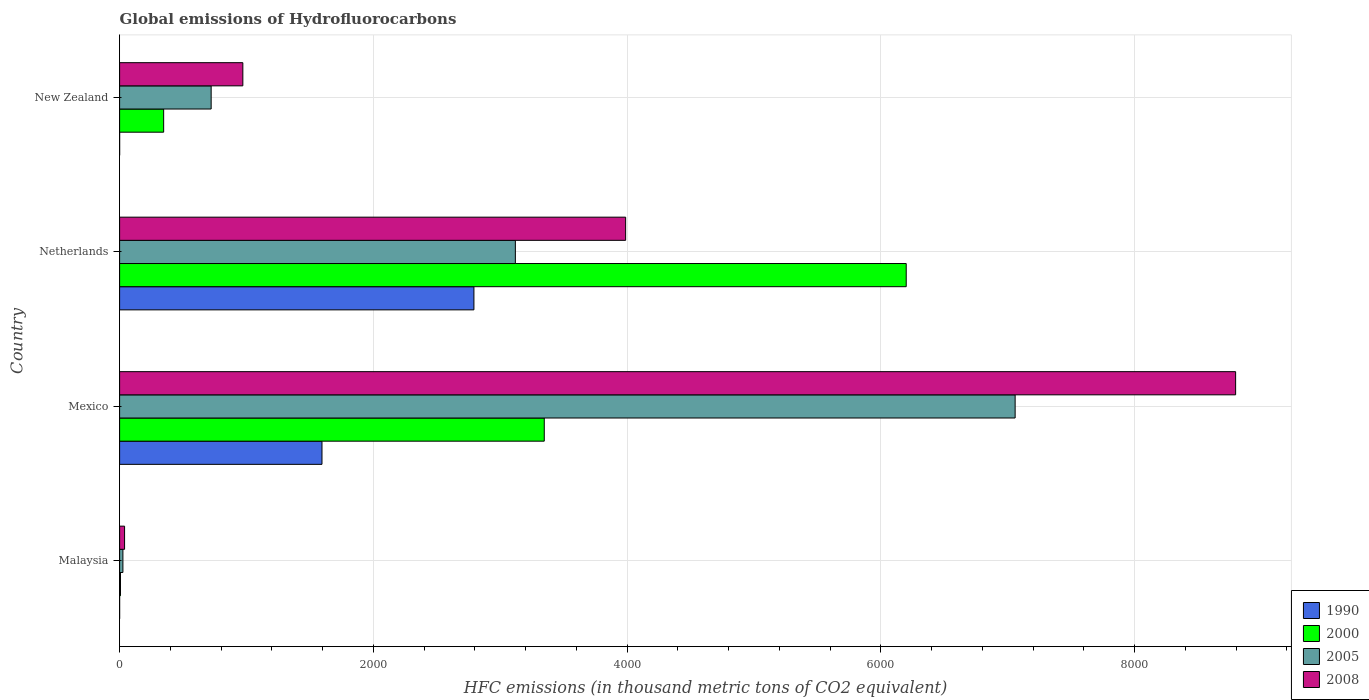Are the number of bars on each tick of the Y-axis equal?
Offer a terse response. Yes. How many bars are there on the 2nd tick from the top?
Your answer should be compact. 4. In how many cases, is the number of bars for a given country not equal to the number of legend labels?
Provide a succinct answer. 0. What is the global emissions of Hydrofluorocarbons in 2008 in New Zealand?
Give a very brief answer. 971.4. Across all countries, what is the maximum global emissions of Hydrofluorocarbons in 1990?
Provide a succinct answer. 2792.9. Across all countries, what is the minimum global emissions of Hydrofluorocarbons in 2005?
Keep it short and to the point. 26.1. In which country was the global emissions of Hydrofluorocarbons in 1990 minimum?
Provide a succinct answer. Malaysia. What is the total global emissions of Hydrofluorocarbons in 2000 in the graph?
Ensure brevity in your answer.  9901.9. What is the difference between the global emissions of Hydrofluorocarbons in 2005 in Malaysia and that in New Zealand?
Your answer should be compact. -695.6. What is the difference between the global emissions of Hydrofluorocarbons in 1990 in Mexico and the global emissions of Hydrofluorocarbons in 2008 in Netherlands?
Your answer should be very brief. -2393.5. What is the average global emissions of Hydrofluorocarbons in 1990 per country?
Provide a short and direct response. 1097.12. What is the difference between the global emissions of Hydrofluorocarbons in 1990 and global emissions of Hydrofluorocarbons in 2000 in Mexico?
Your answer should be compact. -1752. In how many countries, is the global emissions of Hydrofluorocarbons in 1990 greater than 4000 thousand metric tons?
Offer a terse response. 0. What is the ratio of the global emissions of Hydrofluorocarbons in 2008 in Mexico to that in New Zealand?
Your response must be concise. 9.06. What is the difference between the highest and the second highest global emissions of Hydrofluorocarbons in 1990?
Provide a short and direct response. 1197.6. What is the difference between the highest and the lowest global emissions of Hydrofluorocarbons in 1990?
Provide a succinct answer. 2792.8. In how many countries, is the global emissions of Hydrofluorocarbons in 2000 greater than the average global emissions of Hydrofluorocarbons in 2000 taken over all countries?
Offer a very short reply. 2. Is the sum of the global emissions of Hydrofluorocarbons in 2008 in Malaysia and Mexico greater than the maximum global emissions of Hydrofluorocarbons in 2000 across all countries?
Your answer should be very brief. Yes. What does the 4th bar from the top in Netherlands represents?
Give a very brief answer. 1990. Is it the case that in every country, the sum of the global emissions of Hydrofluorocarbons in 2008 and global emissions of Hydrofluorocarbons in 2000 is greater than the global emissions of Hydrofluorocarbons in 1990?
Give a very brief answer. Yes. How many bars are there?
Offer a very short reply. 16. What is the difference between two consecutive major ticks on the X-axis?
Provide a short and direct response. 2000. Are the values on the major ticks of X-axis written in scientific E-notation?
Your answer should be compact. No. Does the graph contain any zero values?
Make the answer very short. No. How are the legend labels stacked?
Your answer should be very brief. Vertical. What is the title of the graph?
Provide a succinct answer. Global emissions of Hydrofluorocarbons. What is the label or title of the X-axis?
Make the answer very short. HFC emissions (in thousand metric tons of CO2 equivalent). What is the HFC emissions (in thousand metric tons of CO2 equivalent) of 2005 in Malaysia?
Make the answer very short. 26.1. What is the HFC emissions (in thousand metric tons of CO2 equivalent) in 2008 in Malaysia?
Give a very brief answer. 39.2. What is the HFC emissions (in thousand metric tons of CO2 equivalent) in 1990 in Mexico?
Offer a terse response. 1595.3. What is the HFC emissions (in thousand metric tons of CO2 equivalent) of 2000 in Mexico?
Keep it short and to the point. 3347.3. What is the HFC emissions (in thousand metric tons of CO2 equivalent) of 2005 in Mexico?
Your answer should be compact. 7058.9. What is the HFC emissions (in thousand metric tons of CO2 equivalent) in 2008 in Mexico?
Give a very brief answer. 8796.9. What is the HFC emissions (in thousand metric tons of CO2 equivalent) of 1990 in Netherlands?
Give a very brief answer. 2792.9. What is the HFC emissions (in thousand metric tons of CO2 equivalent) in 2000 in Netherlands?
Ensure brevity in your answer.  6200.4. What is the HFC emissions (in thousand metric tons of CO2 equivalent) in 2005 in Netherlands?
Offer a terse response. 3119.5. What is the HFC emissions (in thousand metric tons of CO2 equivalent) of 2008 in Netherlands?
Provide a short and direct response. 3988.8. What is the HFC emissions (in thousand metric tons of CO2 equivalent) of 1990 in New Zealand?
Provide a succinct answer. 0.2. What is the HFC emissions (in thousand metric tons of CO2 equivalent) of 2000 in New Zealand?
Ensure brevity in your answer.  347.3. What is the HFC emissions (in thousand metric tons of CO2 equivalent) in 2005 in New Zealand?
Offer a very short reply. 721.7. What is the HFC emissions (in thousand metric tons of CO2 equivalent) of 2008 in New Zealand?
Give a very brief answer. 971.4. Across all countries, what is the maximum HFC emissions (in thousand metric tons of CO2 equivalent) of 1990?
Make the answer very short. 2792.9. Across all countries, what is the maximum HFC emissions (in thousand metric tons of CO2 equivalent) in 2000?
Provide a short and direct response. 6200.4. Across all countries, what is the maximum HFC emissions (in thousand metric tons of CO2 equivalent) of 2005?
Make the answer very short. 7058.9. Across all countries, what is the maximum HFC emissions (in thousand metric tons of CO2 equivalent) in 2008?
Provide a short and direct response. 8796.9. Across all countries, what is the minimum HFC emissions (in thousand metric tons of CO2 equivalent) of 2005?
Your answer should be compact. 26.1. Across all countries, what is the minimum HFC emissions (in thousand metric tons of CO2 equivalent) of 2008?
Your answer should be compact. 39.2. What is the total HFC emissions (in thousand metric tons of CO2 equivalent) in 1990 in the graph?
Offer a terse response. 4388.5. What is the total HFC emissions (in thousand metric tons of CO2 equivalent) of 2000 in the graph?
Offer a terse response. 9901.9. What is the total HFC emissions (in thousand metric tons of CO2 equivalent) in 2005 in the graph?
Offer a very short reply. 1.09e+04. What is the total HFC emissions (in thousand metric tons of CO2 equivalent) in 2008 in the graph?
Your response must be concise. 1.38e+04. What is the difference between the HFC emissions (in thousand metric tons of CO2 equivalent) in 1990 in Malaysia and that in Mexico?
Provide a succinct answer. -1595.2. What is the difference between the HFC emissions (in thousand metric tons of CO2 equivalent) in 2000 in Malaysia and that in Mexico?
Offer a terse response. -3340.4. What is the difference between the HFC emissions (in thousand metric tons of CO2 equivalent) in 2005 in Malaysia and that in Mexico?
Provide a succinct answer. -7032.8. What is the difference between the HFC emissions (in thousand metric tons of CO2 equivalent) in 2008 in Malaysia and that in Mexico?
Your answer should be compact. -8757.7. What is the difference between the HFC emissions (in thousand metric tons of CO2 equivalent) in 1990 in Malaysia and that in Netherlands?
Ensure brevity in your answer.  -2792.8. What is the difference between the HFC emissions (in thousand metric tons of CO2 equivalent) in 2000 in Malaysia and that in Netherlands?
Provide a succinct answer. -6193.5. What is the difference between the HFC emissions (in thousand metric tons of CO2 equivalent) in 2005 in Malaysia and that in Netherlands?
Provide a succinct answer. -3093.4. What is the difference between the HFC emissions (in thousand metric tons of CO2 equivalent) in 2008 in Malaysia and that in Netherlands?
Give a very brief answer. -3949.6. What is the difference between the HFC emissions (in thousand metric tons of CO2 equivalent) of 2000 in Malaysia and that in New Zealand?
Your answer should be very brief. -340.4. What is the difference between the HFC emissions (in thousand metric tons of CO2 equivalent) of 2005 in Malaysia and that in New Zealand?
Provide a short and direct response. -695.6. What is the difference between the HFC emissions (in thousand metric tons of CO2 equivalent) of 2008 in Malaysia and that in New Zealand?
Your answer should be very brief. -932.2. What is the difference between the HFC emissions (in thousand metric tons of CO2 equivalent) in 1990 in Mexico and that in Netherlands?
Make the answer very short. -1197.6. What is the difference between the HFC emissions (in thousand metric tons of CO2 equivalent) in 2000 in Mexico and that in Netherlands?
Give a very brief answer. -2853.1. What is the difference between the HFC emissions (in thousand metric tons of CO2 equivalent) in 2005 in Mexico and that in Netherlands?
Offer a very short reply. 3939.4. What is the difference between the HFC emissions (in thousand metric tons of CO2 equivalent) of 2008 in Mexico and that in Netherlands?
Your response must be concise. 4808.1. What is the difference between the HFC emissions (in thousand metric tons of CO2 equivalent) of 1990 in Mexico and that in New Zealand?
Keep it short and to the point. 1595.1. What is the difference between the HFC emissions (in thousand metric tons of CO2 equivalent) in 2000 in Mexico and that in New Zealand?
Your answer should be compact. 3000. What is the difference between the HFC emissions (in thousand metric tons of CO2 equivalent) of 2005 in Mexico and that in New Zealand?
Give a very brief answer. 6337.2. What is the difference between the HFC emissions (in thousand metric tons of CO2 equivalent) of 2008 in Mexico and that in New Zealand?
Provide a short and direct response. 7825.5. What is the difference between the HFC emissions (in thousand metric tons of CO2 equivalent) in 1990 in Netherlands and that in New Zealand?
Make the answer very short. 2792.7. What is the difference between the HFC emissions (in thousand metric tons of CO2 equivalent) of 2000 in Netherlands and that in New Zealand?
Offer a very short reply. 5853.1. What is the difference between the HFC emissions (in thousand metric tons of CO2 equivalent) of 2005 in Netherlands and that in New Zealand?
Your answer should be compact. 2397.8. What is the difference between the HFC emissions (in thousand metric tons of CO2 equivalent) of 2008 in Netherlands and that in New Zealand?
Provide a succinct answer. 3017.4. What is the difference between the HFC emissions (in thousand metric tons of CO2 equivalent) in 1990 in Malaysia and the HFC emissions (in thousand metric tons of CO2 equivalent) in 2000 in Mexico?
Provide a short and direct response. -3347.2. What is the difference between the HFC emissions (in thousand metric tons of CO2 equivalent) in 1990 in Malaysia and the HFC emissions (in thousand metric tons of CO2 equivalent) in 2005 in Mexico?
Give a very brief answer. -7058.8. What is the difference between the HFC emissions (in thousand metric tons of CO2 equivalent) of 1990 in Malaysia and the HFC emissions (in thousand metric tons of CO2 equivalent) of 2008 in Mexico?
Your answer should be compact. -8796.8. What is the difference between the HFC emissions (in thousand metric tons of CO2 equivalent) of 2000 in Malaysia and the HFC emissions (in thousand metric tons of CO2 equivalent) of 2005 in Mexico?
Your answer should be compact. -7052. What is the difference between the HFC emissions (in thousand metric tons of CO2 equivalent) in 2000 in Malaysia and the HFC emissions (in thousand metric tons of CO2 equivalent) in 2008 in Mexico?
Your answer should be very brief. -8790. What is the difference between the HFC emissions (in thousand metric tons of CO2 equivalent) in 2005 in Malaysia and the HFC emissions (in thousand metric tons of CO2 equivalent) in 2008 in Mexico?
Ensure brevity in your answer.  -8770.8. What is the difference between the HFC emissions (in thousand metric tons of CO2 equivalent) of 1990 in Malaysia and the HFC emissions (in thousand metric tons of CO2 equivalent) of 2000 in Netherlands?
Your response must be concise. -6200.3. What is the difference between the HFC emissions (in thousand metric tons of CO2 equivalent) of 1990 in Malaysia and the HFC emissions (in thousand metric tons of CO2 equivalent) of 2005 in Netherlands?
Your answer should be very brief. -3119.4. What is the difference between the HFC emissions (in thousand metric tons of CO2 equivalent) of 1990 in Malaysia and the HFC emissions (in thousand metric tons of CO2 equivalent) of 2008 in Netherlands?
Offer a terse response. -3988.7. What is the difference between the HFC emissions (in thousand metric tons of CO2 equivalent) in 2000 in Malaysia and the HFC emissions (in thousand metric tons of CO2 equivalent) in 2005 in Netherlands?
Ensure brevity in your answer.  -3112.6. What is the difference between the HFC emissions (in thousand metric tons of CO2 equivalent) in 2000 in Malaysia and the HFC emissions (in thousand metric tons of CO2 equivalent) in 2008 in Netherlands?
Your answer should be compact. -3981.9. What is the difference between the HFC emissions (in thousand metric tons of CO2 equivalent) in 2005 in Malaysia and the HFC emissions (in thousand metric tons of CO2 equivalent) in 2008 in Netherlands?
Ensure brevity in your answer.  -3962.7. What is the difference between the HFC emissions (in thousand metric tons of CO2 equivalent) of 1990 in Malaysia and the HFC emissions (in thousand metric tons of CO2 equivalent) of 2000 in New Zealand?
Ensure brevity in your answer.  -347.2. What is the difference between the HFC emissions (in thousand metric tons of CO2 equivalent) in 1990 in Malaysia and the HFC emissions (in thousand metric tons of CO2 equivalent) in 2005 in New Zealand?
Keep it short and to the point. -721.6. What is the difference between the HFC emissions (in thousand metric tons of CO2 equivalent) in 1990 in Malaysia and the HFC emissions (in thousand metric tons of CO2 equivalent) in 2008 in New Zealand?
Keep it short and to the point. -971.3. What is the difference between the HFC emissions (in thousand metric tons of CO2 equivalent) of 2000 in Malaysia and the HFC emissions (in thousand metric tons of CO2 equivalent) of 2005 in New Zealand?
Keep it short and to the point. -714.8. What is the difference between the HFC emissions (in thousand metric tons of CO2 equivalent) in 2000 in Malaysia and the HFC emissions (in thousand metric tons of CO2 equivalent) in 2008 in New Zealand?
Give a very brief answer. -964.5. What is the difference between the HFC emissions (in thousand metric tons of CO2 equivalent) in 2005 in Malaysia and the HFC emissions (in thousand metric tons of CO2 equivalent) in 2008 in New Zealand?
Provide a short and direct response. -945.3. What is the difference between the HFC emissions (in thousand metric tons of CO2 equivalent) of 1990 in Mexico and the HFC emissions (in thousand metric tons of CO2 equivalent) of 2000 in Netherlands?
Make the answer very short. -4605.1. What is the difference between the HFC emissions (in thousand metric tons of CO2 equivalent) of 1990 in Mexico and the HFC emissions (in thousand metric tons of CO2 equivalent) of 2005 in Netherlands?
Give a very brief answer. -1524.2. What is the difference between the HFC emissions (in thousand metric tons of CO2 equivalent) in 1990 in Mexico and the HFC emissions (in thousand metric tons of CO2 equivalent) in 2008 in Netherlands?
Provide a succinct answer. -2393.5. What is the difference between the HFC emissions (in thousand metric tons of CO2 equivalent) of 2000 in Mexico and the HFC emissions (in thousand metric tons of CO2 equivalent) of 2005 in Netherlands?
Your answer should be very brief. 227.8. What is the difference between the HFC emissions (in thousand metric tons of CO2 equivalent) in 2000 in Mexico and the HFC emissions (in thousand metric tons of CO2 equivalent) in 2008 in Netherlands?
Your answer should be compact. -641.5. What is the difference between the HFC emissions (in thousand metric tons of CO2 equivalent) of 2005 in Mexico and the HFC emissions (in thousand metric tons of CO2 equivalent) of 2008 in Netherlands?
Make the answer very short. 3070.1. What is the difference between the HFC emissions (in thousand metric tons of CO2 equivalent) of 1990 in Mexico and the HFC emissions (in thousand metric tons of CO2 equivalent) of 2000 in New Zealand?
Ensure brevity in your answer.  1248. What is the difference between the HFC emissions (in thousand metric tons of CO2 equivalent) of 1990 in Mexico and the HFC emissions (in thousand metric tons of CO2 equivalent) of 2005 in New Zealand?
Offer a terse response. 873.6. What is the difference between the HFC emissions (in thousand metric tons of CO2 equivalent) in 1990 in Mexico and the HFC emissions (in thousand metric tons of CO2 equivalent) in 2008 in New Zealand?
Your answer should be very brief. 623.9. What is the difference between the HFC emissions (in thousand metric tons of CO2 equivalent) in 2000 in Mexico and the HFC emissions (in thousand metric tons of CO2 equivalent) in 2005 in New Zealand?
Your answer should be very brief. 2625.6. What is the difference between the HFC emissions (in thousand metric tons of CO2 equivalent) in 2000 in Mexico and the HFC emissions (in thousand metric tons of CO2 equivalent) in 2008 in New Zealand?
Give a very brief answer. 2375.9. What is the difference between the HFC emissions (in thousand metric tons of CO2 equivalent) in 2005 in Mexico and the HFC emissions (in thousand metric tons of CO2 equivalent) in 2008 in New Zealand?
Keep it short and to the point. 6087.5. What is the difference between the HFC emissions (in thousand metric tons of CO2 equivalent) of 1990 in Netherlands and the HFC emissions (in thousand metric tons of CO2 equivalent) of 2000 in New Zealand?
Provide a short and direct response. 2445.6. What is the difference between the HFC emissions (in thousand metric tons of CO2 equivalent) in 1990 in Netherlands and the HFC emissions (in thousand metric tons of CO2 equivalent) in 2005 in New Zealand?
Your answer should be very brief. 2071.2. What is the difference between the HFC emissions (in thousand metric tons of CO2 equivalent) in 1990 in Netherlands and the HFC emissions (in thousand metric tons of CO2 equivalent) in 2008 in New Zealand?
Make the answer very short. 1821.5. What is the difference between the HFC emissions (in thousand metric tons of CO2 equivalent) of 2000 in Netherlands and the HFC emissions (in thousand metric tons of CO2 equivalent) of 2005 in New Zealand?
Your response must be concise. 5478.7. What is the difference between the HFC emissions (in thousand metric tons of CO2 equivalent) of 2000 in Netherlands and the HFC emissions (in thousand metric tons of CO2 equivalent) of 2008 in New Zealand?
Provide a short and direct response. 5229. What is the difference between the HFC emissions (in thousand metric tons of CO2 equivalent) in 2005 in Netherlands and the HFC emissions (in thousand metric tons of CO2 equivalent) in 2008 in New Zealand?
Keep it short and to the point. 2148.1. What is the average HFC emissions (in thousand metric tons of CO2 equivalent) in 1990 per country?
Keep it short and to the point. 1097.12. What is the average HFC emissions (in thousand metric tons of CO2 equivalent) of 2000 per country?
Provide a short and direct response. 2475.47. What is the average HFC emissions (in thousand metric tons of CO2 equivalent) of 2005 per country?
Keep it short and to the point. 2731.55. What is the average HFC emissions (in thousand metric tons of CO2 equivalent) in 2008 per country?
Offer a very short reply. 3449.07. What is the difference between the HFC emissions (in thousand metric tons of CO2 equivalent) of 1990 and HFC emissions (in thousand metric tons of CO2 equivalent) of 2000 in Malaysia?
Your answer should be compact. -6.8. What is the difference between the HFC emissions (in thousand metric tons of CO2 equivalent) of 1990 and HFC emissions (in thousand metric tons of CO2 equivalent) of 2005 in Malaysia?
Your response must be concise. -26. What is the difference between the HFC emissions (in thousand metric tons of CO2 equivalent) in 1990 and HFC emissions (in thousand metric tons of CO2 equivalent) in 2008 in Malaysia?
Offer a very short reply. -39.1. What is the difference between the HFC emissions (in thousand metric tons of CO2 equivalent) in 2000 and HFC emissions (in thousand metric tons of CO2 equivalent) in 2005 in Malaysia?
Give a very brief answer. -19.2. What is the difference between the HFC emissions (in thousand metric tons of CO2 equivalent) of 2000 and HFC emissions (in thousand metric tons of CO2 equivalent) of 2008 in Malaysia?
Make the answer very short. -32.3. What is the difference between the HFC emissions (in thousand metric tons of CO2 equivalent) of 2005 and HFC emissions (in thousand metric tons of CO2 equivalent) of 2008 in Malaysia?
Ensure brevity in your answer.  -13.1. What is the difference between the HFC emissions (in thousand metric tons of CO2 equivalent) in 1990 and HFC emissions (in thousand metric tons of CO2 equivalent) in 2000 in Mexico?
Ensure brevity in your answer.  -1752. What is the difference between the HFC emissions (in thousand metric tons of CO2 equivalent) in 1990 and HFC emissions (in thousand metric tons of CO2 equivalent) in 2005 in Mexico?
Give a very brief answer. -5463.6. What is the difference between the HFC emissions (in thousand metric tons of CO2 equivalent) in 1990 and HFC emissions (in thousand metric tons of CO2 equivalent) in 2008 in Mexico?
Your answer should be compact. -7201.6. What is the difference between the HFC emissions (in thousand metric tons of CO2 equivalent) in 2000 and HFC emissions (in thousand metric tons of CO2 equivalent) in 2005 in Mexico?
Give a very brief answer. -3711.6. What is the difference between the HFC emissions (in thousand metric tons of CO2 equivalent) of 2000 and HFC emissions (in thousand metric tons of CO2 equivalent) of 2008 in Mexico?
Your answer should be very brief. -5449.6. What is the difference between the HFC emissions (in thousand metric tons of CO2 equivalent) of 2005 and HFC emissions (in thousand metric tons of CO2 equivalent) of 2008 in Mexico?
Give a very brief answer. -1738. What is the difference between the HFC emissions (in thousand metric tons of CO2 equivalent) in 1990 and HFC emissions (in thousand metric tons of CO2 equivalent) in 2000 in Netherlands?
Your response must be concise. -3407.5. What is the difference between the HFC emissions (in thousand metric tons of CO2 equivalent) in 1990 and HFC emissions (in thousand metric tons of CO2 equivalent) in 2005 in Netherlands?
Make the answer very short. -326.6. What is the difference between the HFC emissions (in thousand metric tons of CO2 equivalent) of 1990 and HFC emissions (in thousand metric tons of CO2 equivalent) of 2008 in Netherlands?
Your response must be concise. -1195.9. What is the difference between the HFC emissions (in thousand metric tons of CO2 equivalent) of 2000 and HFC emissions (in thousand metric tons of CO2 equivalent) of 2005 in Netherlands?
Your response must be concise. 3080.9. What is the difference between the HFC emissions (in thousand metric tons of CO2 equivalent) of 2000 and HFC emissions (in thousand metric tons of CO2 equivalent) of 2008 in Netherlands?
Your answer should be compact. 2211.6. What is the difference between the HFC emissions (in thousand metric tons of CO2 equivalent) of 2005 and HFC emissions (in thousand metric tons of CO2 equivalent) of 2008 in Netherlands?
Your answer should be compact. -869.3. What is the difference between the HFC emissions (in thousand metric tons of CO2 equivalent) in 1990 and HFC emissions (in thousand metric tons of CO2 equivalent) in 2000 in New Zealand?
Ensure brevity in your answer.  -347.1. What is the difference between the HFC emissions (in thousand metric tons of CO2 equivalent) of 1990 and HFC emissions (in thousand metric tons of CO2 equivalent) of 2005 in New Zealand?
Give a very brief answer. -721.5. What is the difference between the HFC emissions (in thousand metric tons of CO2 equivalent) of 1990 and HFC emissions (in thousand metric tons of CO2 equivalent) of 2008 in New Zealand?
Give a very brief answer. -971.2. What is the difference between the HFC emissions (in thousand metric tons of CO2 equivalent) in 2000 and HFC emissions (in thousand metric tons of CO2 equivalent) in 2005 in New Zealand?
Your answer should be very brief. -374.4. What is the difference between the HFC emissions (in thousand metric tons of CO2 equivalent) of 2000 and HFC emissions (in thousand metric tons of CO2 equivalent) of 2008 in New Zealand?
Keep it short and to the point. -624.1. What is the difference between the HFC emissions (in thousand metric tons of CO2 equivalent) in 2005 and HFC emissions (in thousand metric tons of CO2 equivalent) in 2008 in New Zealand?
Provide a succinct answer. -249.7. What is the ratio of the HFC emissions (in thousand metric tons of CO2 equivalent) of 2000 in Malaysia to that in Mexico?
Provide a short and direct response. 0. What is the ratio of the HFC emissions (in thousand metric tons of CO2 equivalent) in 2005 in Malaysia to that in Mexico?
Keep it short and to the point. 0. What is the ratio of the HFC emissions (in thousand metric tons of CO2 equivalent) in 2008 in Malaysia to that in Mexico?
Give a very brief answer. 0. What is the ratio of the HFC emissions (in thousand metric tons of CO2 equivalent) of 1990 in Malaysia to that in Netherlands?
Your response must be concise. 0. What is the ratio of the HFC emissions (in thousand metric tons of CO2 equivalent) of 2000 in Malaysia to that in Netherlands?
Offer a terse response. 0. What is the ratio of the HFC emissions (in thousand metric tons of CO2 equivalent) of 2005 in Malaysia to that in Netherlands?
Ensure brevity in your answer.  0.01. What is the ratio of the HFC emissions (in thousand metric tons of CO2 equivalent) of 2008 in Malaysia to that in Netherlands?
Your answer should be very brief. 0.01. What is the ratio of the HFC emissions (in thousand metric tons of CO2 equivalent) of 1990 in Malaysia to that in New Zealand?
Give a very brief answer. 0.5. What is the ratio of the HFC emissions (in thousand metric tons of CO2 equivalent) of 2000 in Malaysia to that in New Zealand?
Your answer should be very brief. 0.02. What is the ratio of the HFC emissions (in thousand metric tons of CO2 equivalent) in 2005 in Malaysia to that in New Zealand?
Your response must be concise. 0.04. What is the ratio of the HFC emissions (in thousand metric tons of CO2 equivalent) of 2008 in Malaysia to that in New Zealand?
Your answer should be very brief. 0.04. What is the ratio of the HFC emissions (in thousand metric tons of CO2 equivalent) in 1990 in Mexico to that in Netherlands?
Keep it short and to the point. 0.57. What is the ratio of the HFC emissions (in thousand metric tons of CO2 equivalent) in 2000 in Mexico to that in Netherlands?
Offer a terse response. 0.54. What is the ratio of the HFC emissions (in thousand metric tons of CO2 equivalent) in 2005 in Mexico to that in Netherlands?
Make the answer very short. 2.26. What is the ratio of the HFC emissions (in thousand metric tons of CO2 equivalent) of 2008 in Mexico to that in Netherlands?
Your response must be concise. 2.21. What is the ratio of the HFC emissions (in thousand metric tons of CO2 equivalent) in 1990 in Mexico to that in New Zealand?
Provide a succinct answer. 7976.5. What is the ratio of the HFC emissions (in thousand metric tons of CO2 equivalent) in 2000 in Mexico to that in New Zealand?
Provide a succinct answer. 9.64. What is the ratio of the HFC emissions (in thousand metric tons of CO2 equivalent) in 2005 in Mexico to that in New Zealand?
Offer a very short reply. 9.78. What is the ratio of the HFC emissions (in thousand metric tons of CO2 equivalent) in 2008 in Mexico to that in New Zealand?
Offer a very short reply. 9.06. What is the ratio of the HFC emissions (in thousand metric tons of CO2 equivalent) of 1990 in Netherlands to that in New Zealand?
Provide a short and direct response. 1.40e+04. What is the ratio of the HFC emissions (in thousand metric tons of CO2 equivalent) in 2000 in Netherlands to that in New Zealand?
Ensure brevity in your answer.  17.85. What is the ratio of the HFC emissions (in thousand metric tons of CO2 equivalent) in 2005 in Netherlands to that in New Zealand?
Your answer should be very brief. 4.32. What is the ratio of the HFC emissions (in thousand metric tons of CO2 equivalent) of 2008 in Netherlands to that in New Zealand?
Your response must be concise. 4.11. What is the difference between the highest and the second highest HFC emissions (in thousand metric tons of CO2 equivalent) of 1990?
Your answer should be compact. 1197.6. What is the difference between the highest and the second highest HFC emissions (in thousand metric tons of CO2 equivalent) in 2000?
Your answer should be compact. 2853.1. What is the difference between the highest and the second highest HFC emissions (in thousand metric tons of CO2 equivalent) of 2005?
Your answer should be compact. 3939.4. What is the difference between the highest and the second highest HFC emissions (in thousand metric tons of CO2 equivalent) of 2008?
Your answer should be compact. 4808.1. What is the difference between the highest and the lowest HFC emissions (in thousand metric tons of CO2 equivalent) of 1990?
Make the answer very short. 2792.8. What is the difference between the highest and the lowest HFC emissions (in thousand metric tons of CO2 equivalent) in 2000?
Ensure brevity in your answer.  6193.5. What is the difference between the highest and the lowest HFC emissions (in thousand metric tons of CO2 equivalent) of 2005?
Make the answer very short. 7032.8. What is the difference between the highest and the lowest HFC emissions (in thousand metric tons of CO2 equivalent) in 2008?
Your response must be concise. 8757.7. 